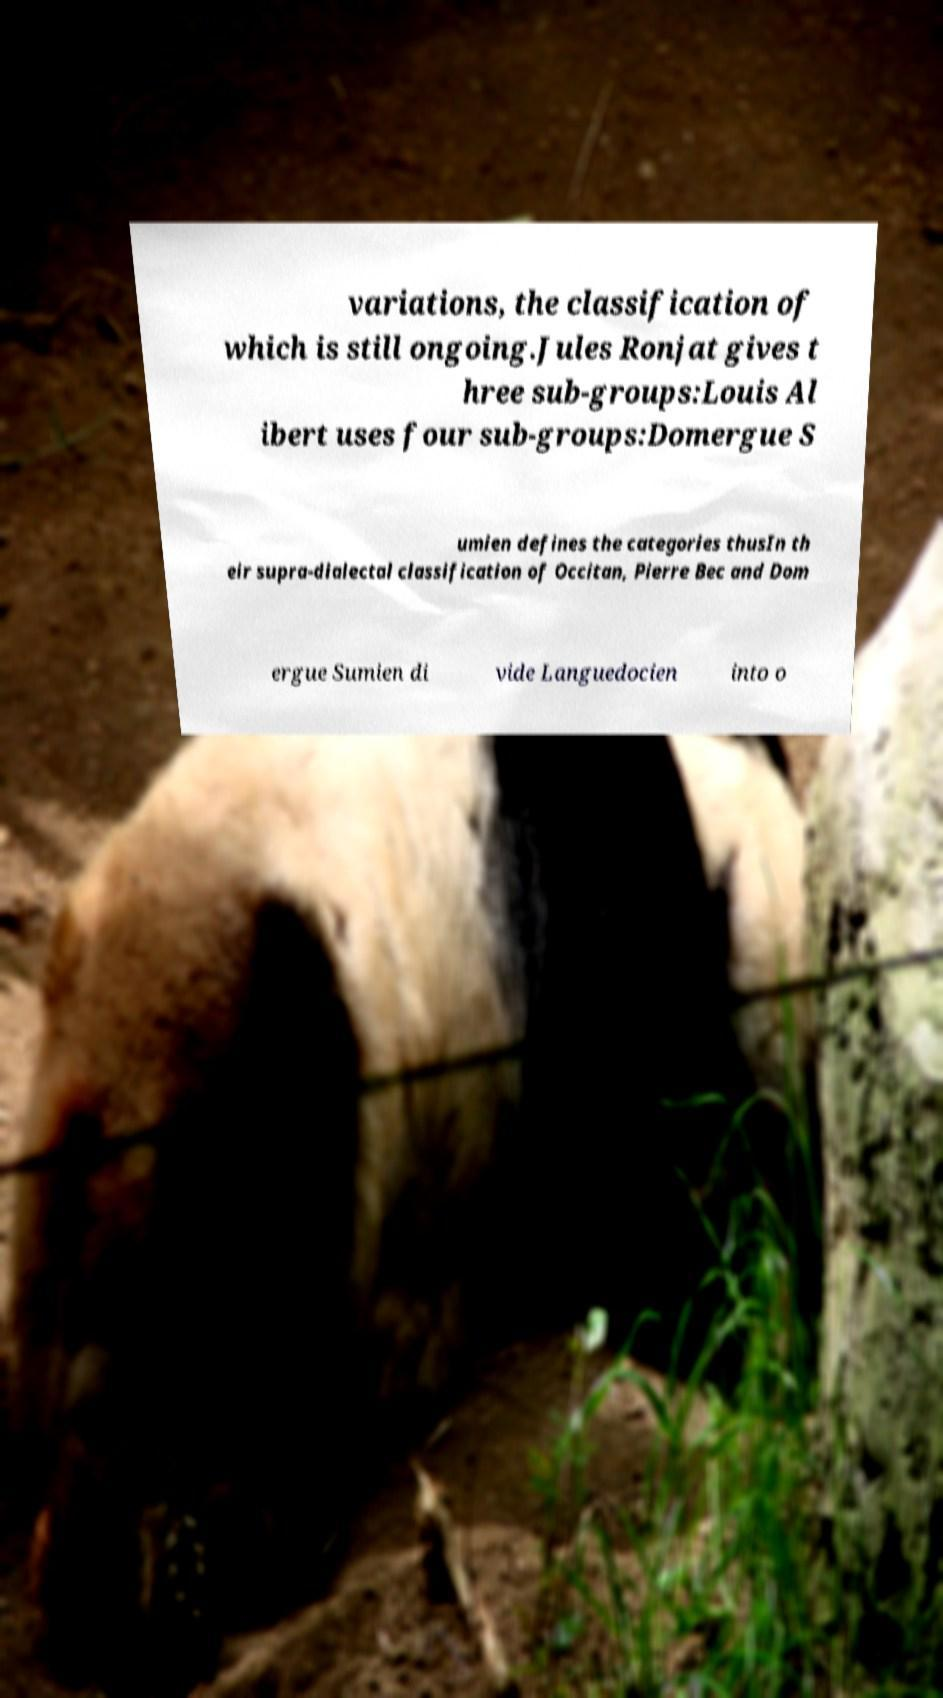Can you accurately transcribe the text from the provided image for me? variations, the classification of which is still ongoing.Jules Ronjat gives t hree sub-groups:Louis Al ibert uses four sub-groups:Domergue S umien defines the categories thusIn th eir supra-dialectal classification of Occitan, Pierre Bec and Dom ergue Sumien di vide Languedocien into o 